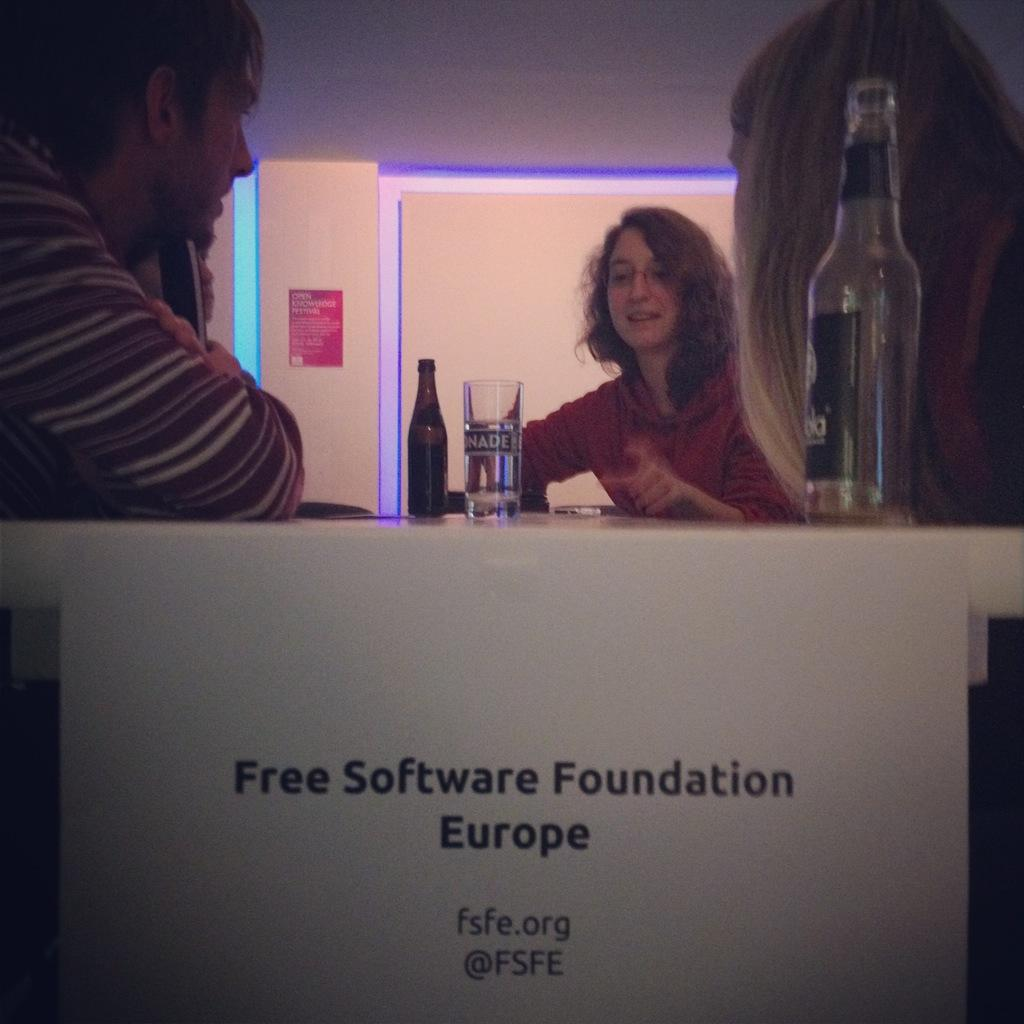How many people are in the image? There are two women and men in the image. What are the people doing in the image? The people are sitting on chairs. What objects can be seen on the table in the image? There is a glass, a bottle, and a phone on the table. What is hanging on the wall in the image? There is a poster on the wall. What type of nut is being cracked open on the table in the image? There is no nut present in the image; the objects on the table are a glass, a bottle, and a phone. 